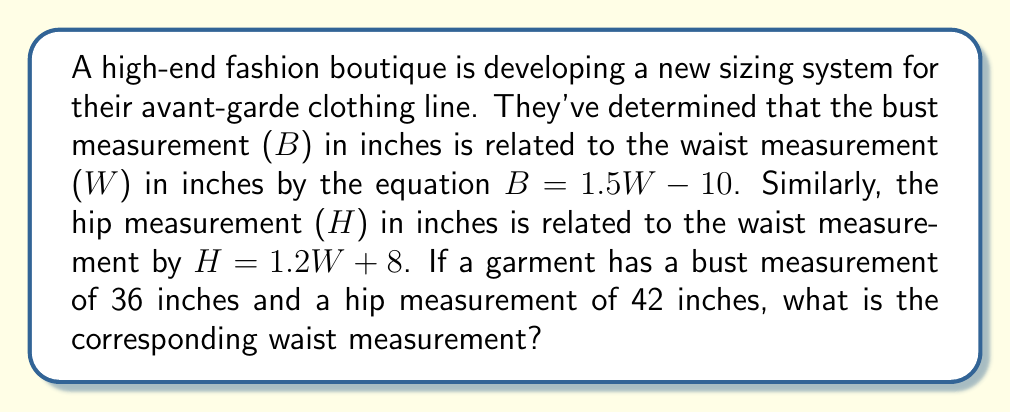Help me with this question. To solve this problem, we'll use a system of linear equations approach:

1. We have two equations relating bust (B) and hip (H) measurements to the waist (W) measurement:
   $$B = 1.5W - 10$$
   $$H = 1.2W + 8$$

2. We're given that B = 36 inches and H = 42 inches. Let's substitute these values:
   $$36 = 1.5W - 10$$
   $$42 = 1.2W + 8$$

3. Now we have a system of two equations with one unknown (W). Let's solve the first equation for W:
   $$36 = 1.5W - 10$$
   $$46 = 1.5W$$
   $$W = \frac{46}{1.5} = 30.67$$

4. To verify, let's plug this value into the second equation:
   $$42 = 1.2(30.67) + 8$$
   $$42 = 36.8 + 8 = 44.8$$

5. The slight discrepancy (42 vs 44.8) is due to rounding. We can conclude that the waist measurement is approximately 30.67 inches.

This system of equations allows us to determine the relationship between different body measurements, which is crucial for creating a cohesive and well-fitting clothing line. The symbolic meaning of these proportions could be explored in the design process, emphasizing the golden ratio or other aesthetic principles.
Answer: The corresponding waist measurement is approximately 30.67 inches. 